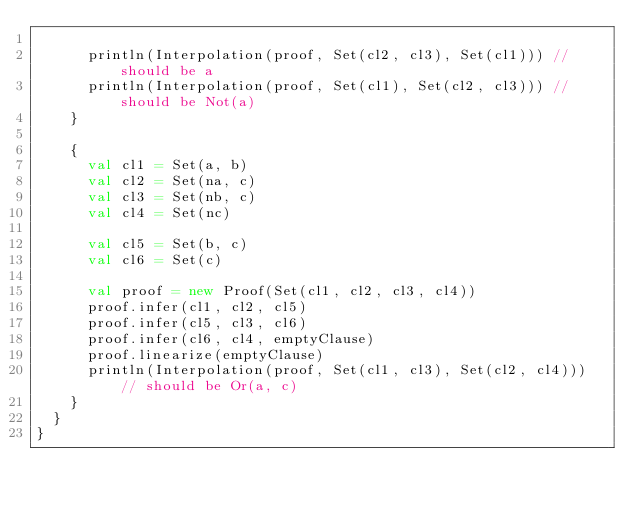<code> <loc_0><loc_0><loc_500><loc_500><_Scala_>
      println(Interpolation(proof, Set(cl2, cl3), Set(cl1))) //should be a
      println(Interpolation(proof, Set(cl1), Set(cl2, cl3))) //should be Not(a)
    }

    {
      val cl1 = Set(a, b)
      val cl2 = Set(na, c)
      val cl3 = Set(nb, c)
      val cl4 = Set(nc)

      val cl5 = Set(b, c)
      val cl6 = Set(c)

      val proof = new Proof(Set(cl1, cl2, cl3, cl4))
      proof.infer(cl1, cl2, cl5)
      proof.infer(cl5, cl3, cl6)
      proof.infer(cl6, cl4, emptyClause)
      proof.linearize(emptyClause)
      println(Interpolation(proof, Set(cl1, cl3), Set(cl2, cl4))) // should be Or(a, c)
    }
  }
}
</code> 